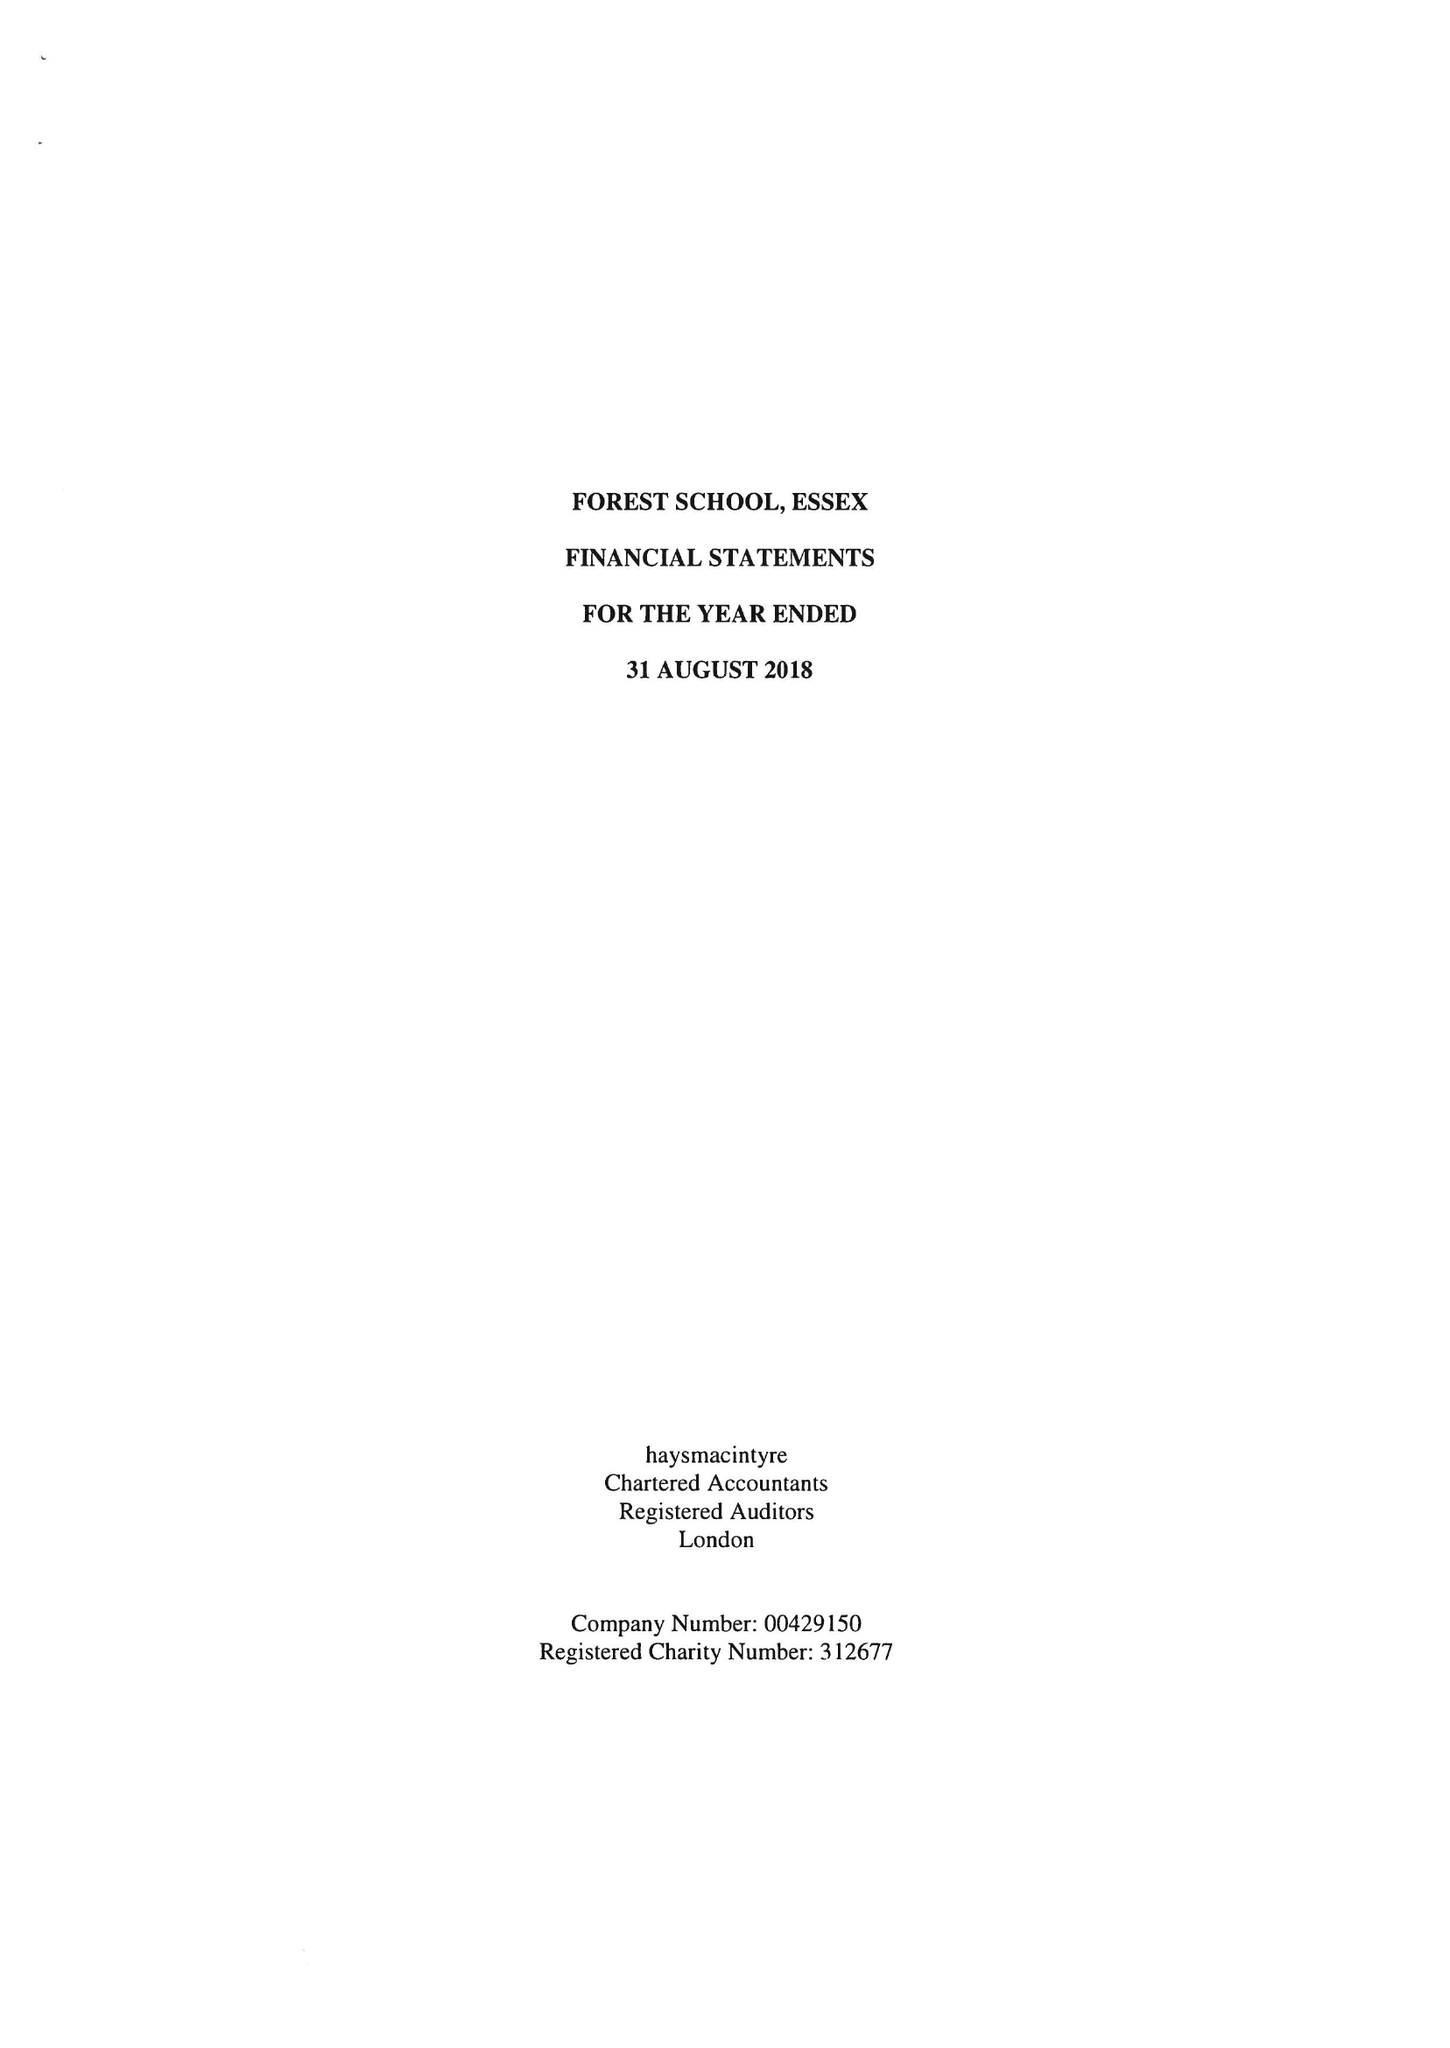What is the value for the address__street_line?
Answer the question using a single word or phrase. COLLEGE PLACE 